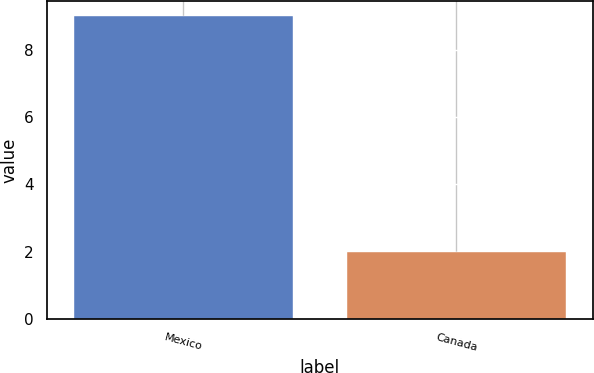<chart> <loc_0><loc_0><loc_500><loc_500><bar_chart><fcel>Mexico<fcel>Canada<nl><fcel>9<fcel>2<nl></chart> 